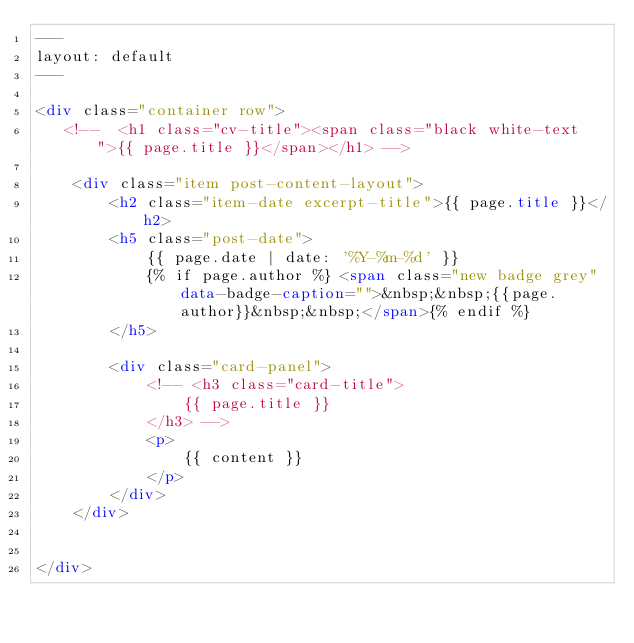Convert code to text. <code><loc_0><loc_0><loc_500><loc_500><_HTML_>---
layout: default
---

<div class="container row">
   <!--  <h1 class="cv-title"><span class="black white-text">{{ page.title }}</span></h1> -->

    <div class="item post-content-layout">
        <h2 class="item-date excerpt-title">{{ page.title }}</h2>
        <h5 class="post-date">
            {{ page.date | date: '%Y-%m-%d' }}
            {% if page.author %} <span class="new badge grey" data-badge-caption="">&nbsp;&nbsp;{{page.author}}&nbsp;&nbsp;</span>{% endif %} 
        </h5>

        <div class="card-panel">
            <!-- <h3 class="card-title">
                {{ page.title }}
            </h3> -->
            <p>
                {{ content }}
            </p>
        </div>
    </div>


</div></code> 